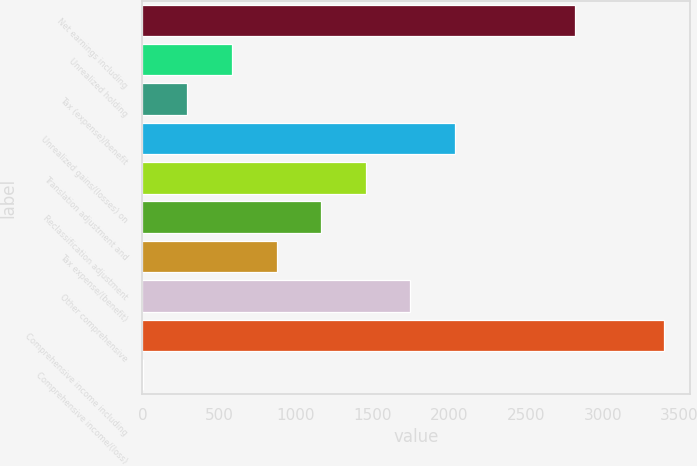Convert chart. <chart><loc_0><loc_0><loc_500><loc_500><bar_chart><fcel>Net earnings including<fcel>Unrealized holding<fcel>Tax (expense)/benefit<fcel>Unrealized gains/(losses) on<fcel>Translation adjustment and<fcel>Reclassification adjustment<fcel>Tax expense/(benefit)<fcel>Other comprehensive<fcel>Comprehensive income including<fcel>Comprehensive income/(loss)<nl><fcel>2818.9<fcel>582.94<fcel>292.07<fcel>2037.29<fcel>1455.55<fcel>1164.68<fcel>873.81<fcel>1746.42<fcel>3400.64<fcel>1.2<nl></chart> 